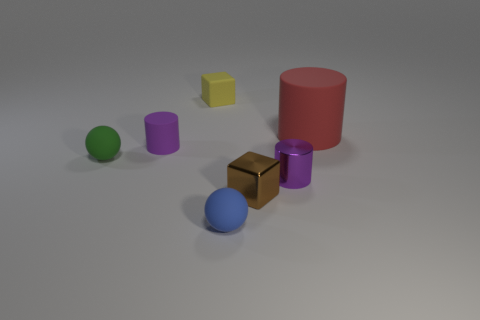There is a object that is the same color as the small rubber cylinder; what is its size?
Your answer should be very brief. Small. There is a small matte object that is the same color as the small shiny cylinder; what is its shape?
Offer a very short reply. Cylinder. What number of things are either rubber cylinders left of the red matte thing or matte cylinders that are in front of the big red object?
Give a very brief answer. 1. Is the tiny object right of the small metal cube made of the same material as the sphere on the right side of the green matte ball?
Ensure brevity in your answer.  No. There is a thing that is left of the matte cylinder in front of the large cylinder; what is its shape?
Provide a succinct answer. Sphere. Is there any other thing that has the same color as the small shiny cylinder?
Give a very brief answer. Yes. There is a block that is on the right side of the tiny block behind the red thing; are there any tiny yellow things behind it?
Your answer should be very brief. Yes. There is a metal thing that is right of the tiny brown metal block; is it the same color as the small block behind the purple matte object?
Make the answer very short. No. There is a brown thing that is the same size as the green matte ball; what is its material?
Provide a short and direct response. Metal. There is a rubber sphere that is left of the tiny object in front of the cube that is in front of the tiny matte cube; how big is it?
Your answer should be very brief. Small. 